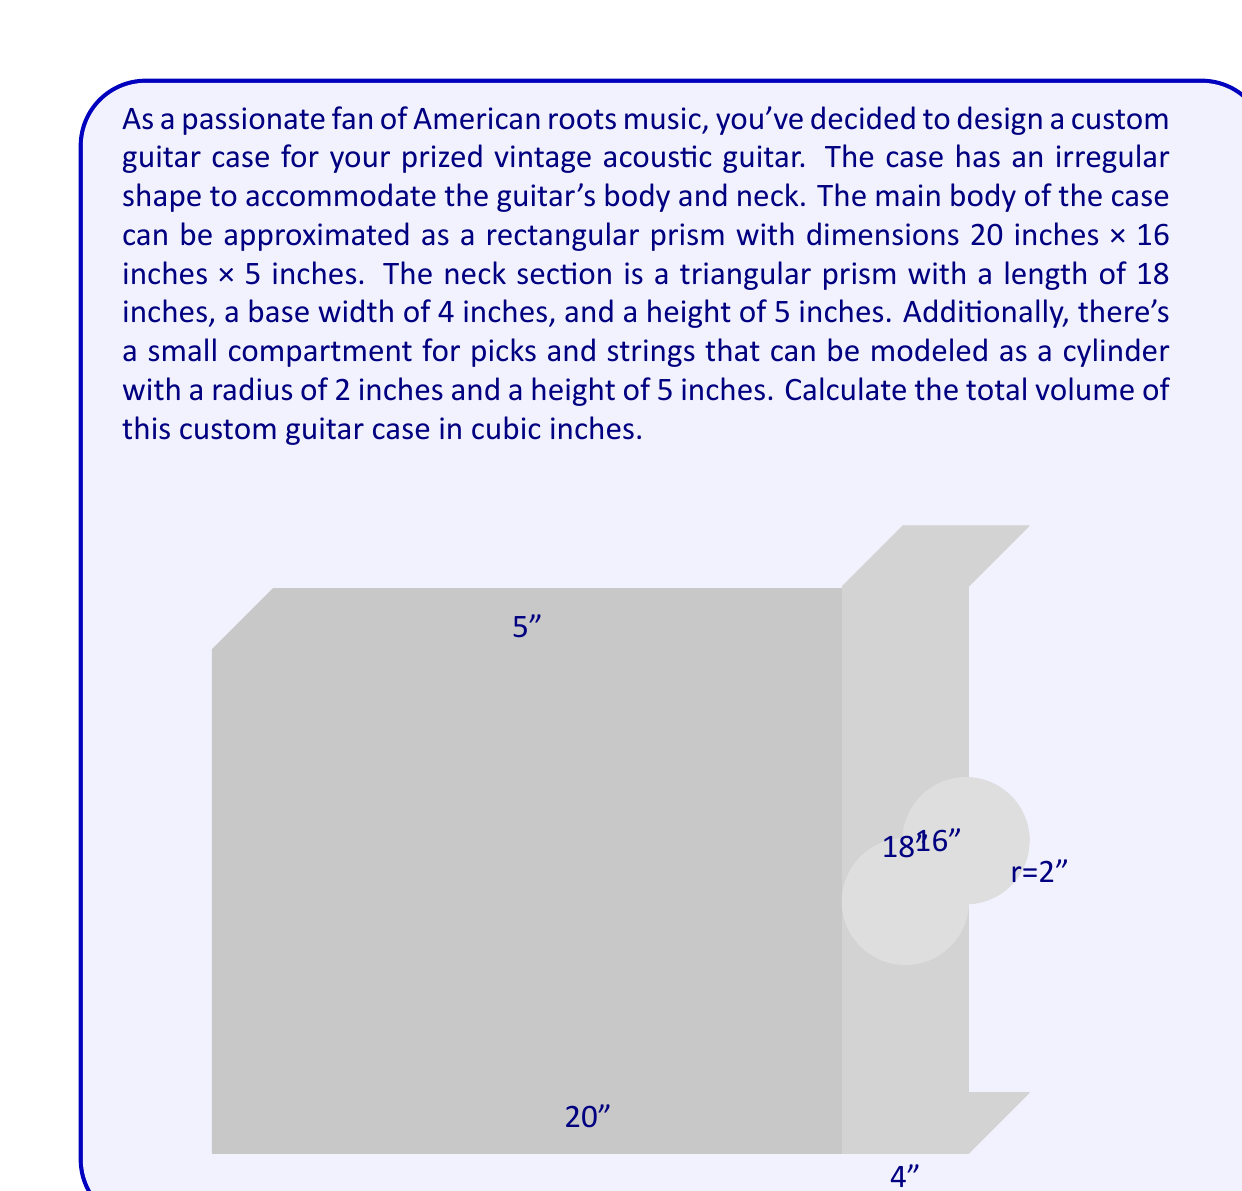Can you answer this question? To find the total volume of the guitar case, we need to calculate the volumes of each component and sum them up:

1. Main body (rectangular prism):
   $V_1 = l \times w \times h = 20 \times 16 \times 5 = 1600$ cubic inches

2. Neck section (triangular prism):
   Base area of triangle: $A = \frac{1}{2} \times base \times height = \frac{1}{2} \times 4 \times 5 = 10$ square inches
   Volume: $V_2 = A \times length = 10 \times 18 = 180$ cubic inches

3. Pick compartment (cylinder):
   $V_3 = \pi r^2 h = \pi \times 2^2 \times 5 = 20\pi$ cubic inches

Total volume:
$$V_{total} = V_1 + V_2 + V_3 = 1600 + 180 + 20\pi$$

$$V_{total} = 1780 + 20\pi \approx 1842.83$$ cubic inches
Answer: $1780 + 20\pi$ cubic inches (or approximately 1842.83 cubic inches) 